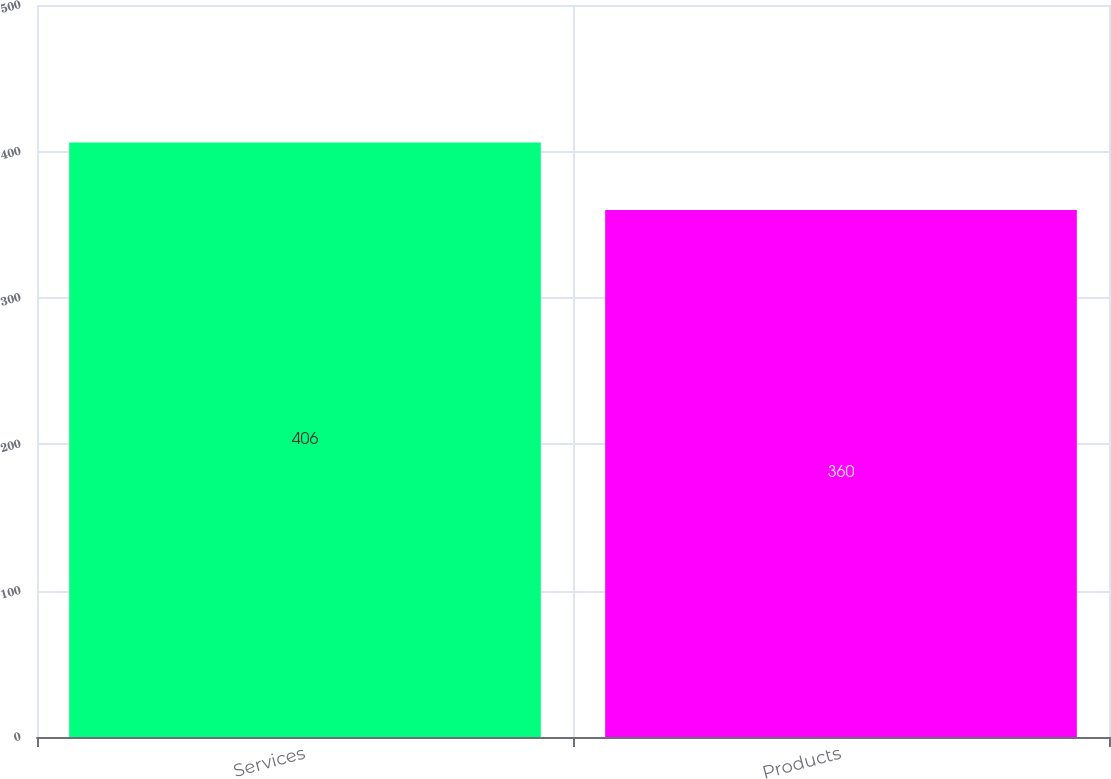<chart> <loc_0><loc_0><loc_500><loc_500><bar_chart><fcel>Services<fcel>Products<nl><fcel>406<fcel>360<nl></chart> 